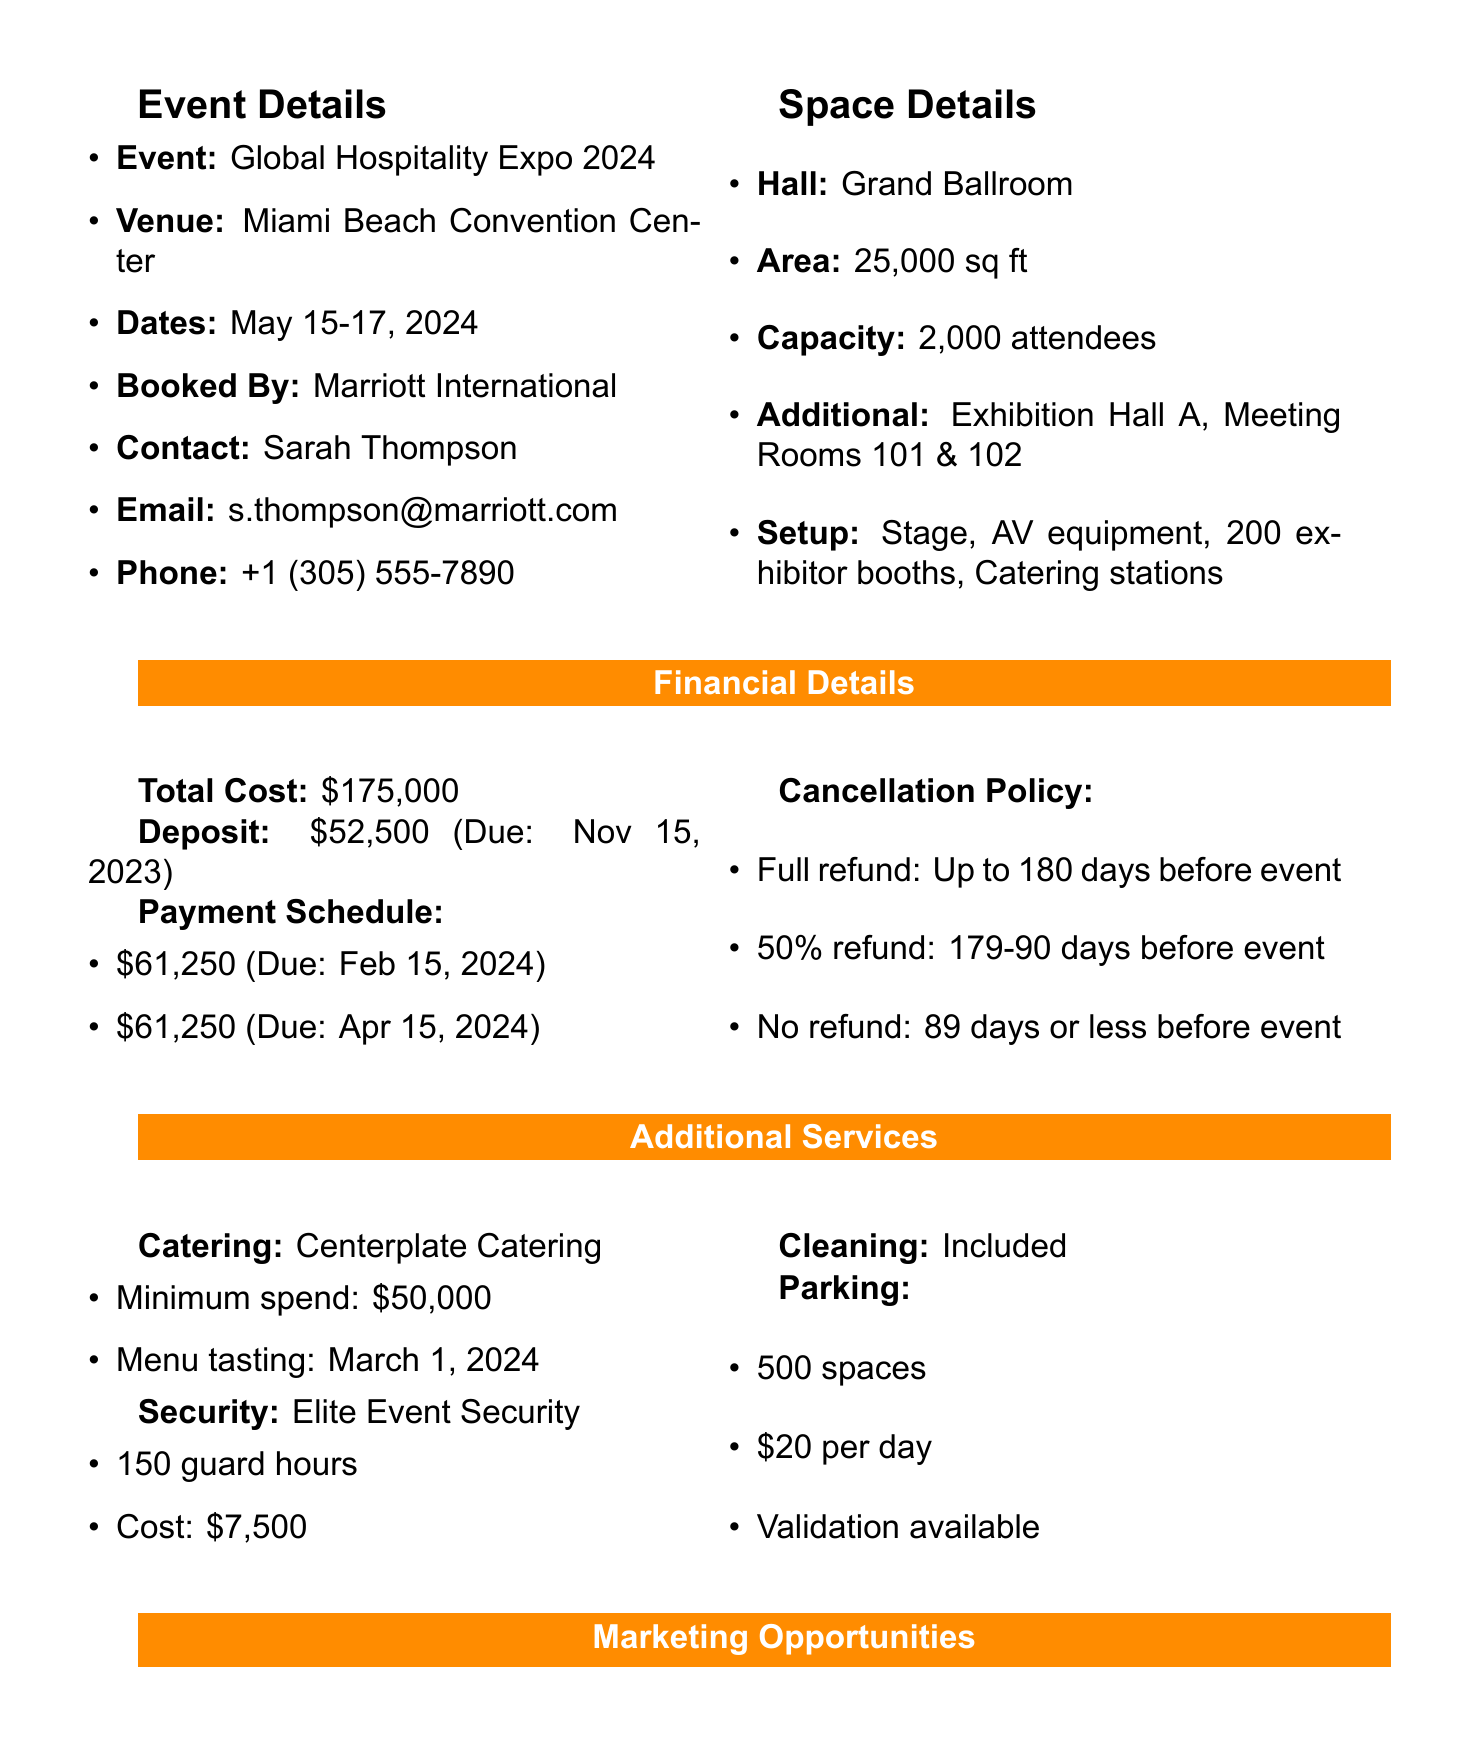what is the booking ID? The booking ID is a unique identifier for the transaction, which is indicated in the document.
Answer: CONV-2023-0589 who is the contact person for the event? The contact person is mentioned in the transaction details, providing a point of contact for any inquiries about the booking.
Answer: Sarah Thompson what is the total cost of the convention center booking? The total cost is specified in the financial details section of the document, representing the overall booking expense.
Answer: $175,000 when is the deposit due? The due date for the deposit is clearly stated in the financial details, indicating when the initial payment is required.
Answer: November 15, 2023 what is the minimum spend for catering? The document specifies the minimum amount that needs to be spent on catering services, providing budget guidance.
Answer: $50,000 how many guard hours are provided by the security service? The document lists the number of guard hours that will be available, which is relevant for event security planning.
Answer: 150 what are the benefits of the Platinum sponsorship package? The benefits of this sponsorship level are provided, highlighting what sponsors will receive for their investment.
Answer: Prime booth location, Speaking opportunity, Logo on all event materials what is the cancellation policy for refunds? The cancellation policy outlines the conditions under which refunds can be granted, an important aspect for planning and risk management.
Answer: Full refund: Up to 180 days before event who is the cleaning service provider? The cleaning service provider is mentioned in the additional services section, detailing who is responsible for this aspect of the event.
Answer: Miami Beach Convention Center 